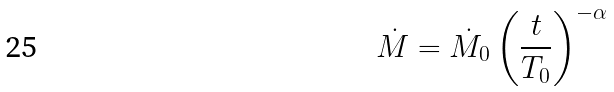Convert formula to latex. <formula><loc_0><loc_0><loc_500><loc_500>\dot { M } = \dot { M } _ { 0 } \left ( \frac { t } { T _ { 0 } } \right ) ^ { - \alpha }</formula> 